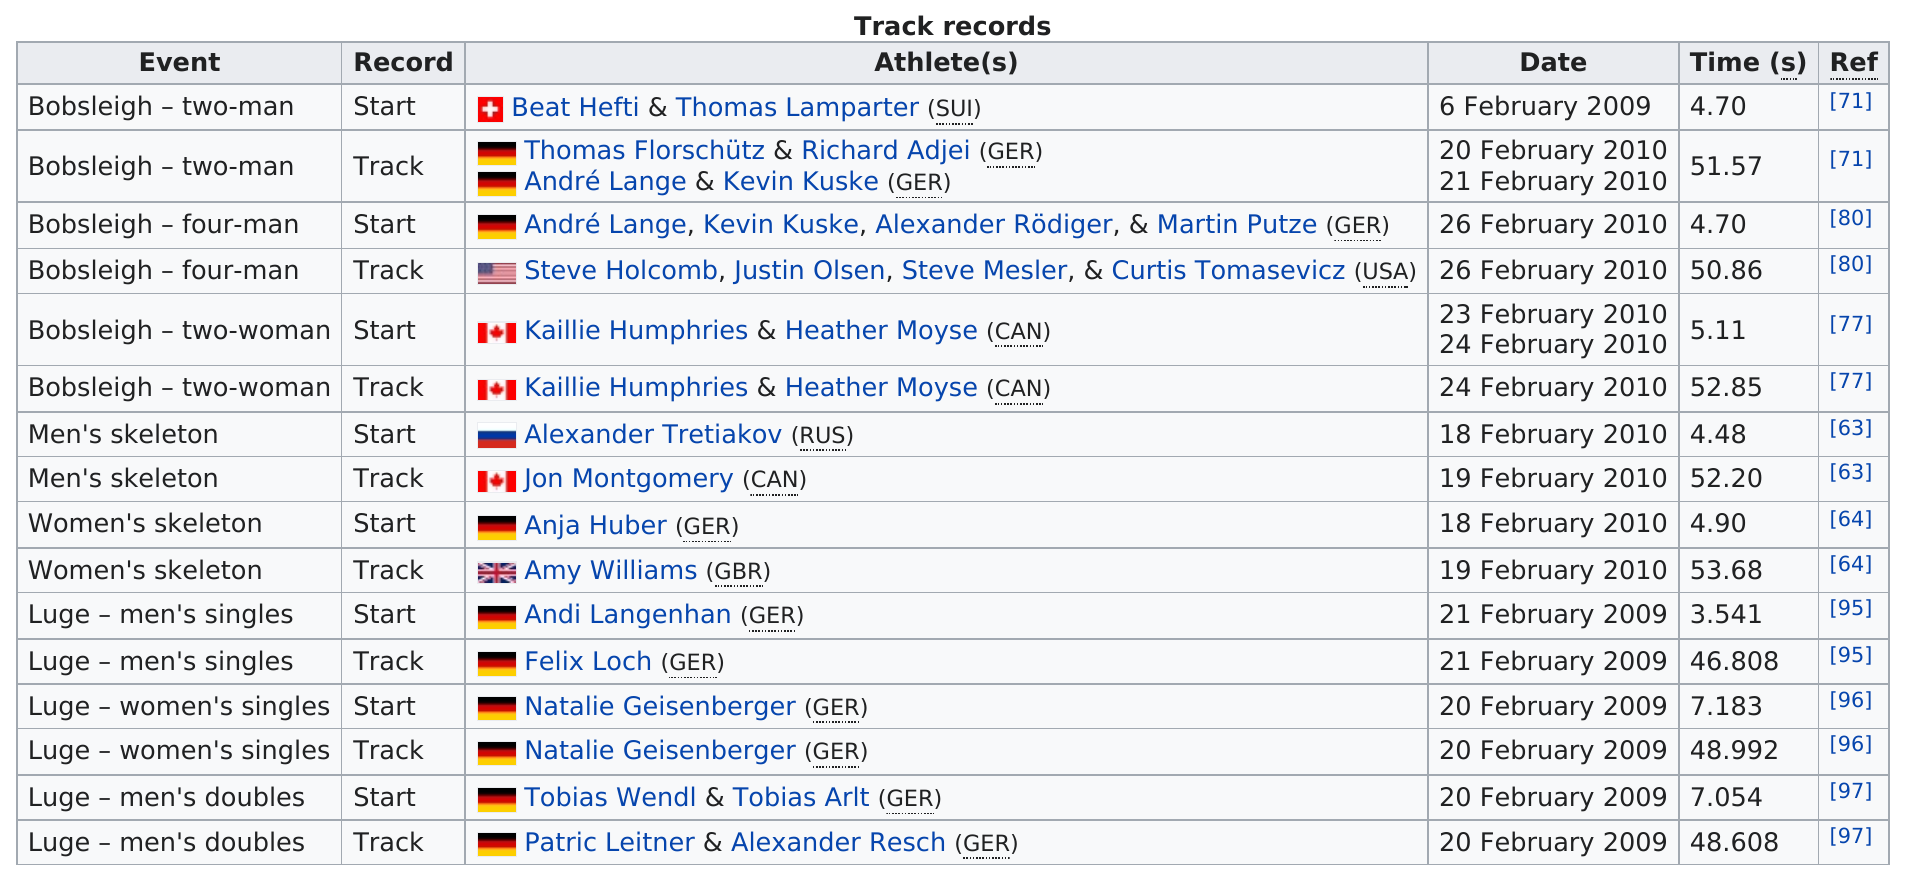Point out several critical features in this image. Felix Loch won the gold medal in the men's luge competition at the 2018 Winter Olympics with a time of 46.808 seconds. In addition to Kaillie Humphries, name the other woman on the Canadian bobsleigh two-woman team. Heather Moyse. The women's skeleton event was the longest to finish. Germany holds more records than Canada. The men's luge singles team from Germany holds the track record. 